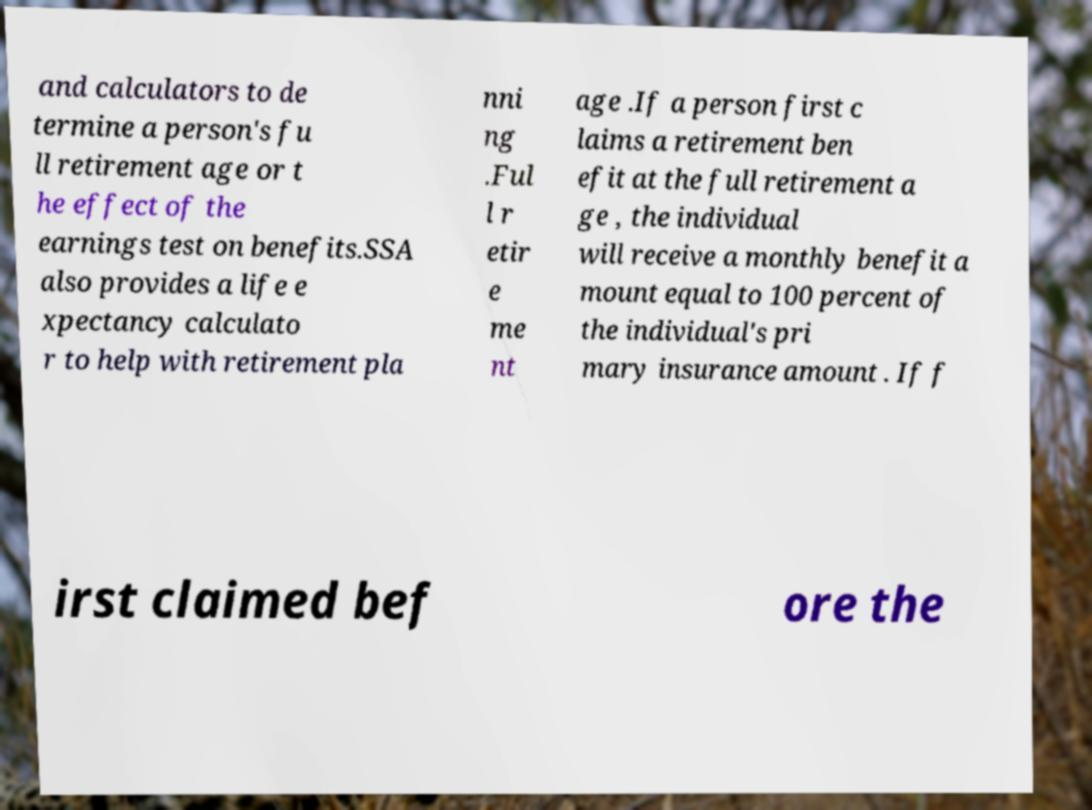I need the written content from this picture converted into text. Can you do that? and calculators to de termine a person's fu ll retirement age or t he effect of the earnings test on benefits.SSA also provides a life e xpectancy calculato r to help with retirement pla nni ng .Ful l r etir e me nt age .If a person first c laims a retirement ben efit at the full retirement a ge , the individual will receive a monthly benefit a mount equal to 100 percent of the individual's pri mary insurance amount . If f irst claimed bef ore the 